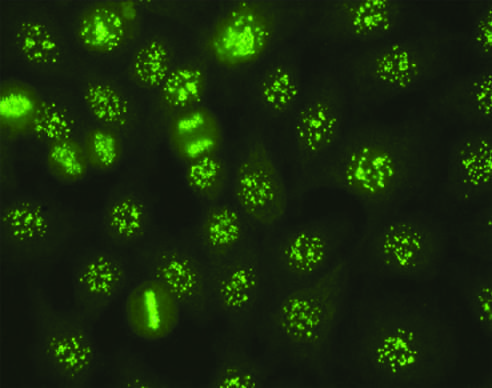s the pattern of staining of anti-centromere antibodies seen in some cases of systemic sclerosis, sjogren syndrome, and other diseases?
Answer the question using a single word or phrase. Yes 